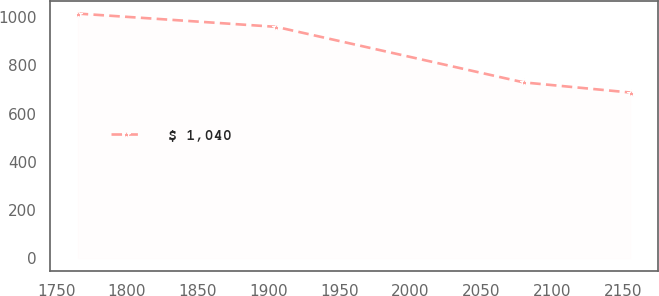Convert chart. <chart><loc_0><loc_0><loc_500><loc_500><line_chart><ecel><fcel>$ 1,040<nl><fcel>1765.18<fcel>1014.36<nl><fcel>1905.31<fcel>959.29<nl><fcel>2080.06<fcel>729.04<nl><fcel>2155.58<fcel>686.89<nl></chart> 